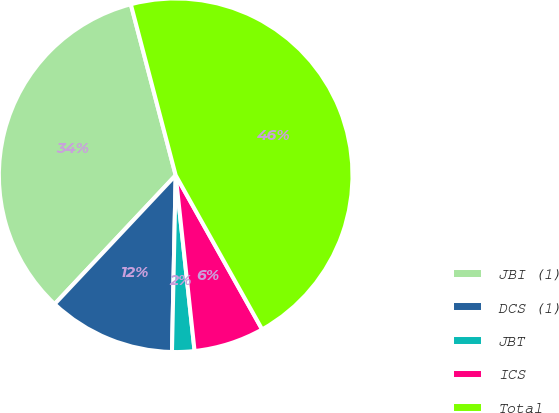Convert chart to OTSL. <chart><loc_0><loc_0><loc_500><loc_500><pie_chart><fcel>JBI (1)<fcel>DCS (1)<fcel>JBT<fcel>ICS<fcel>Total<nl><fcel>33.91%<fcel>11.67%<fcel>2.04%<fcel>6.43%<fcel>45.95%<nl></chart> 